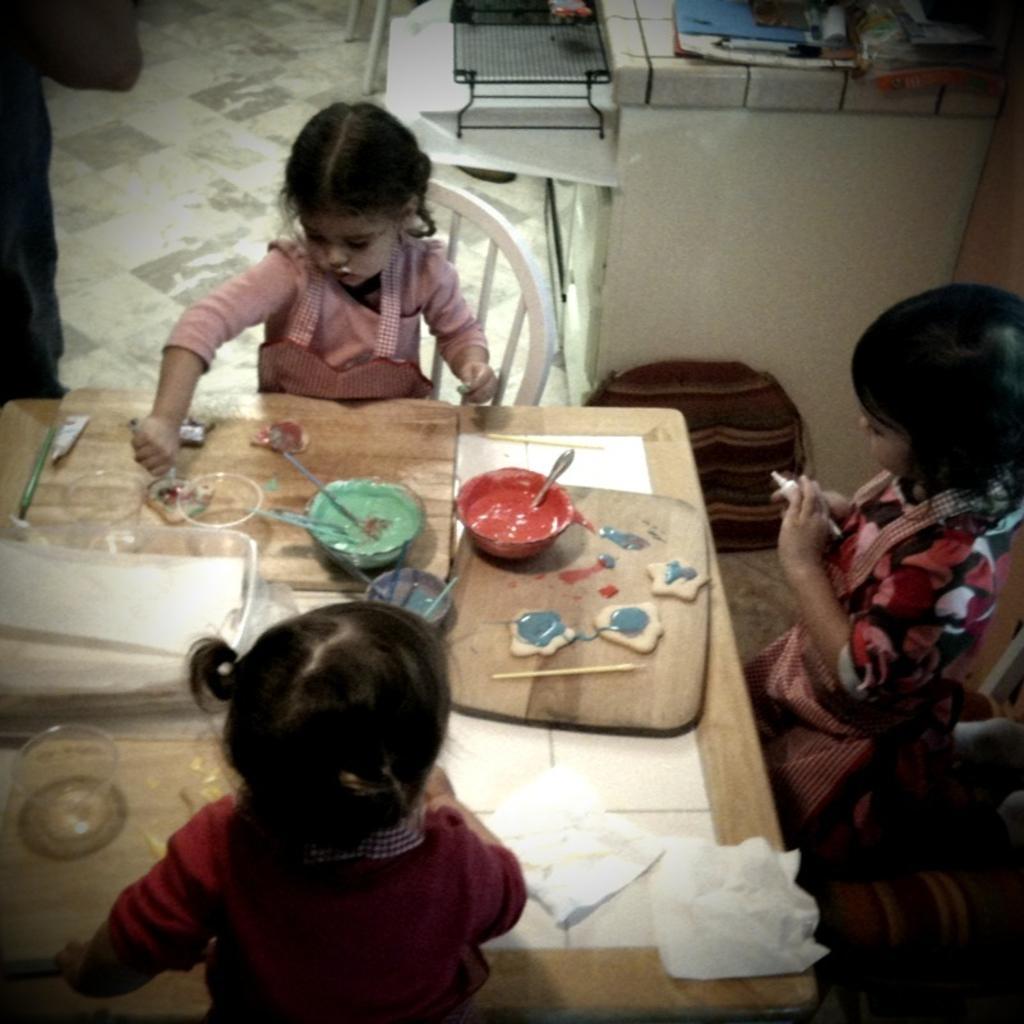Can you describe this image briefly? In this image, There is a table which is in yellow color and there are some bowls on the table, There are some kids sitting on the chairs, In the background there is a white color desk and there are some objects placed in black color and there is a floor in white color. 